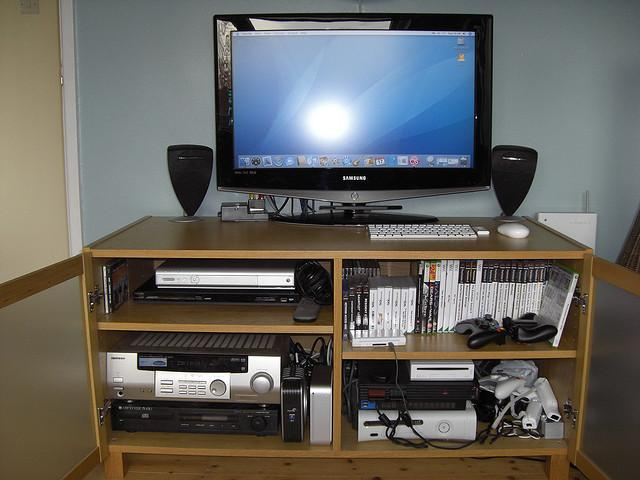What is the purpose of this setup?

Choices:
A) physical enhancement
B) sustenance
C) physical pleasure
D) entertainment entertainment 